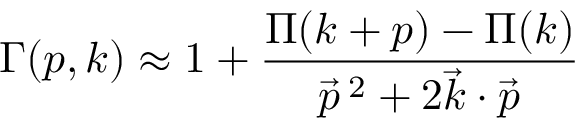Convert formula to latex. <formula><loc_0><loc_0><loc_500><loc_500>\Gamma ( p , k ) \approx 1 + \frac { \Pi ( k + p ) - \Pi ( k ) } { { \vec { p } } \, ^ { 2 } + 2 { \vec { k } } \cdot { \vec { p } } }</formula> 